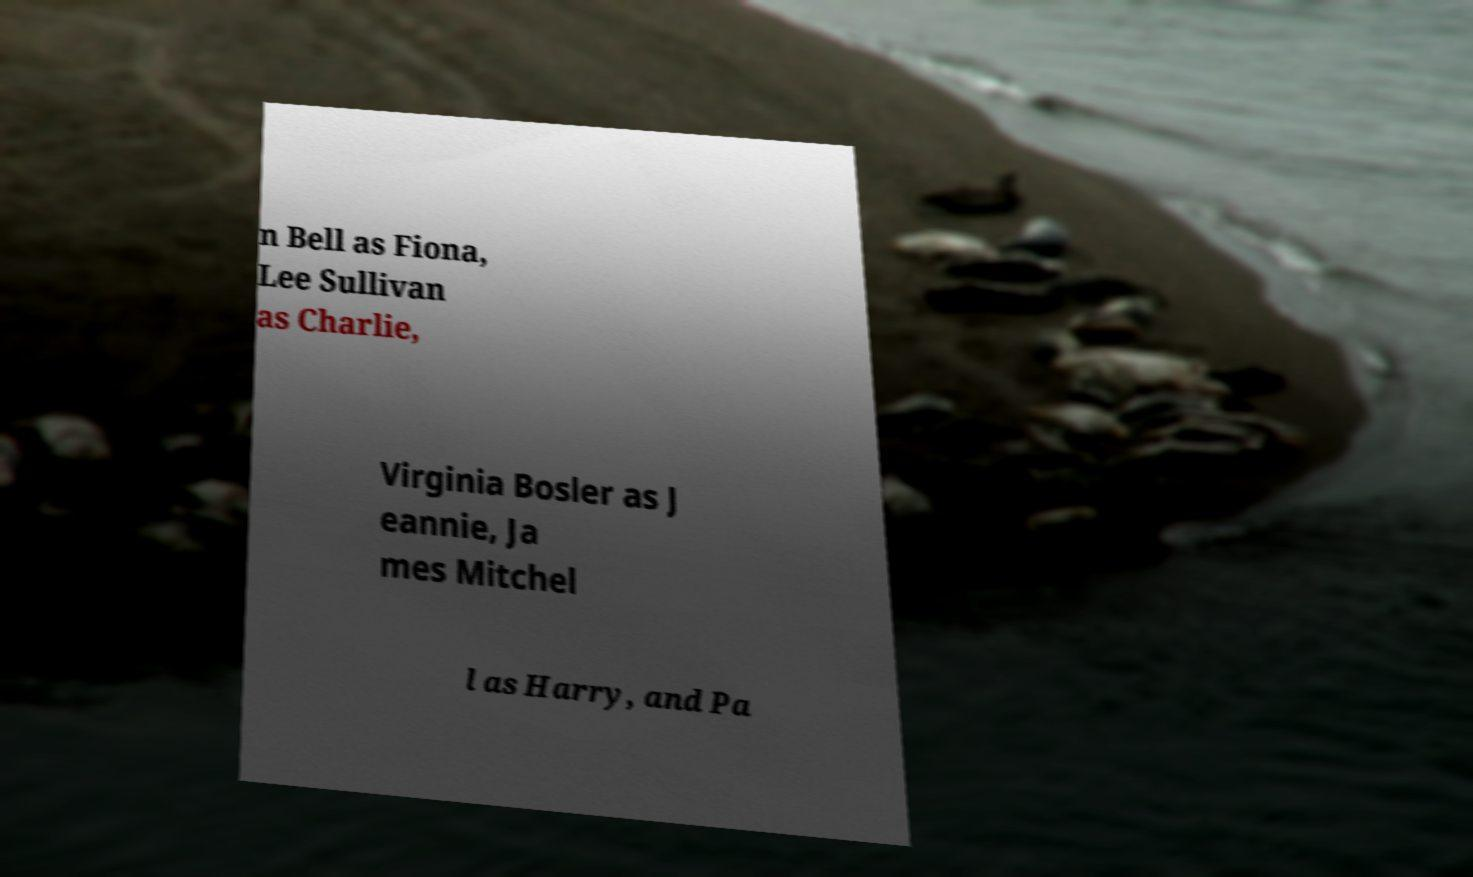Please identify and transcribe the text found in this image. n Bell as Fiona, Lee Sullivan as Charlie, Virginia Bosler as J eannie, Ja mes Mitchel l as Harry, and Pa 